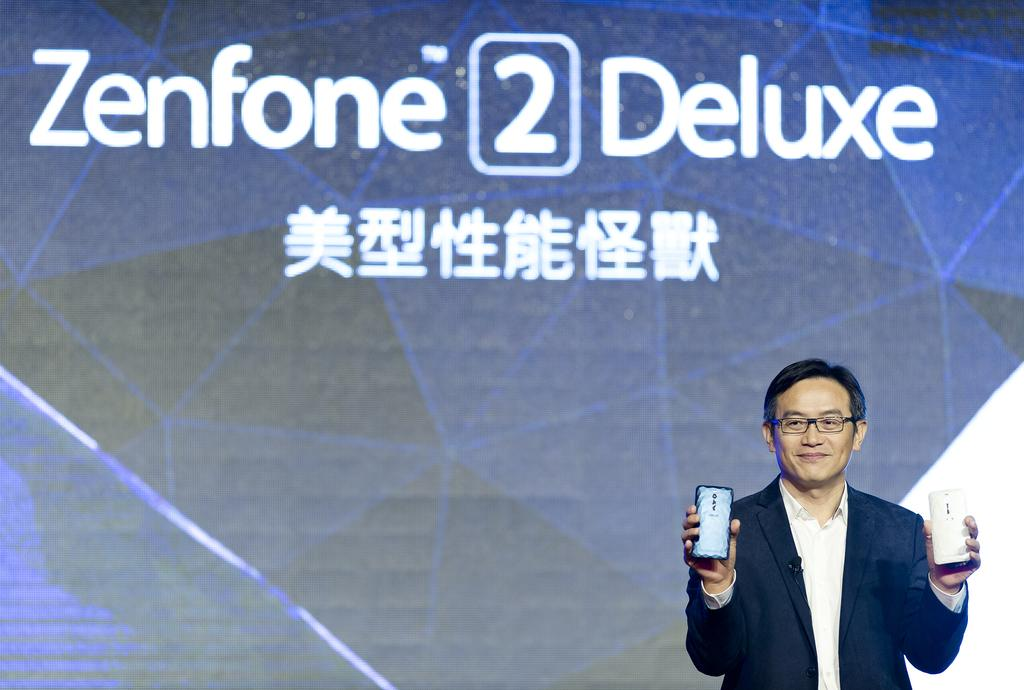What is the main subject of the picture? The main subject of the picture is a man. Can you describe the man's attire? The man is wearing a blue suit. What is the man holding in his hands? The man is holding two phones in his hands. What type of dress is the man wearing in the picture? The man is not wearing a dress; he is wearing a blue suit. Can you see any pigs in the picture? There are no pigs present in the image. 